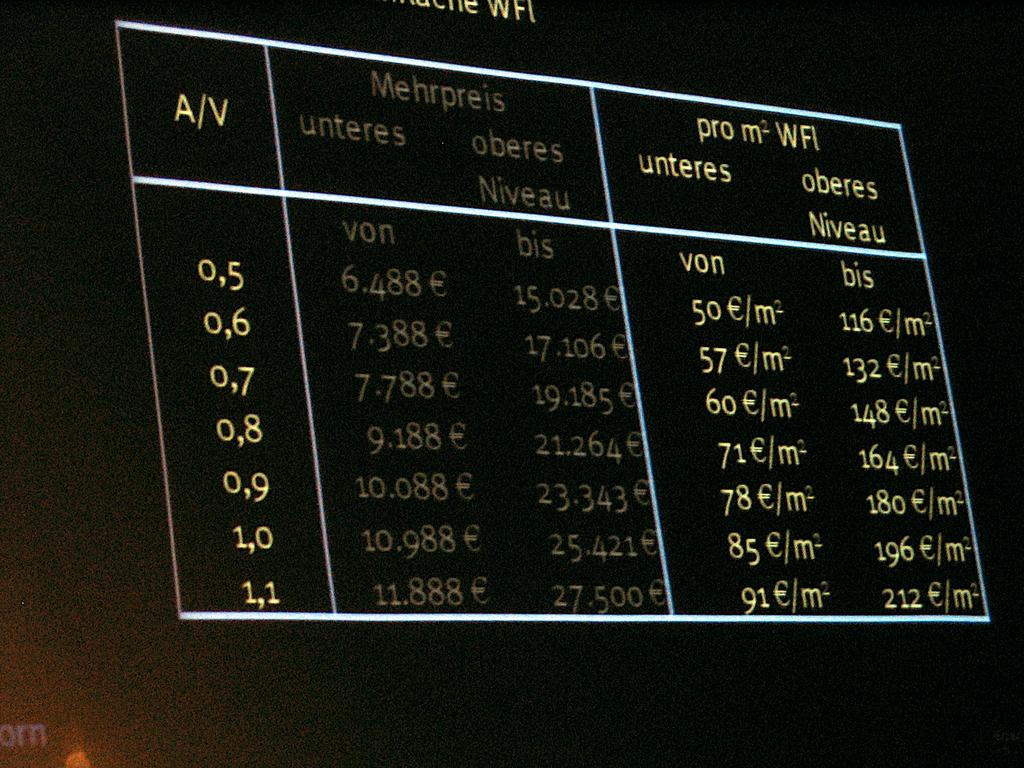Provide a one-sentence caption for the provided image. A electronic board displaying Mehrpreis on it in red and green. 